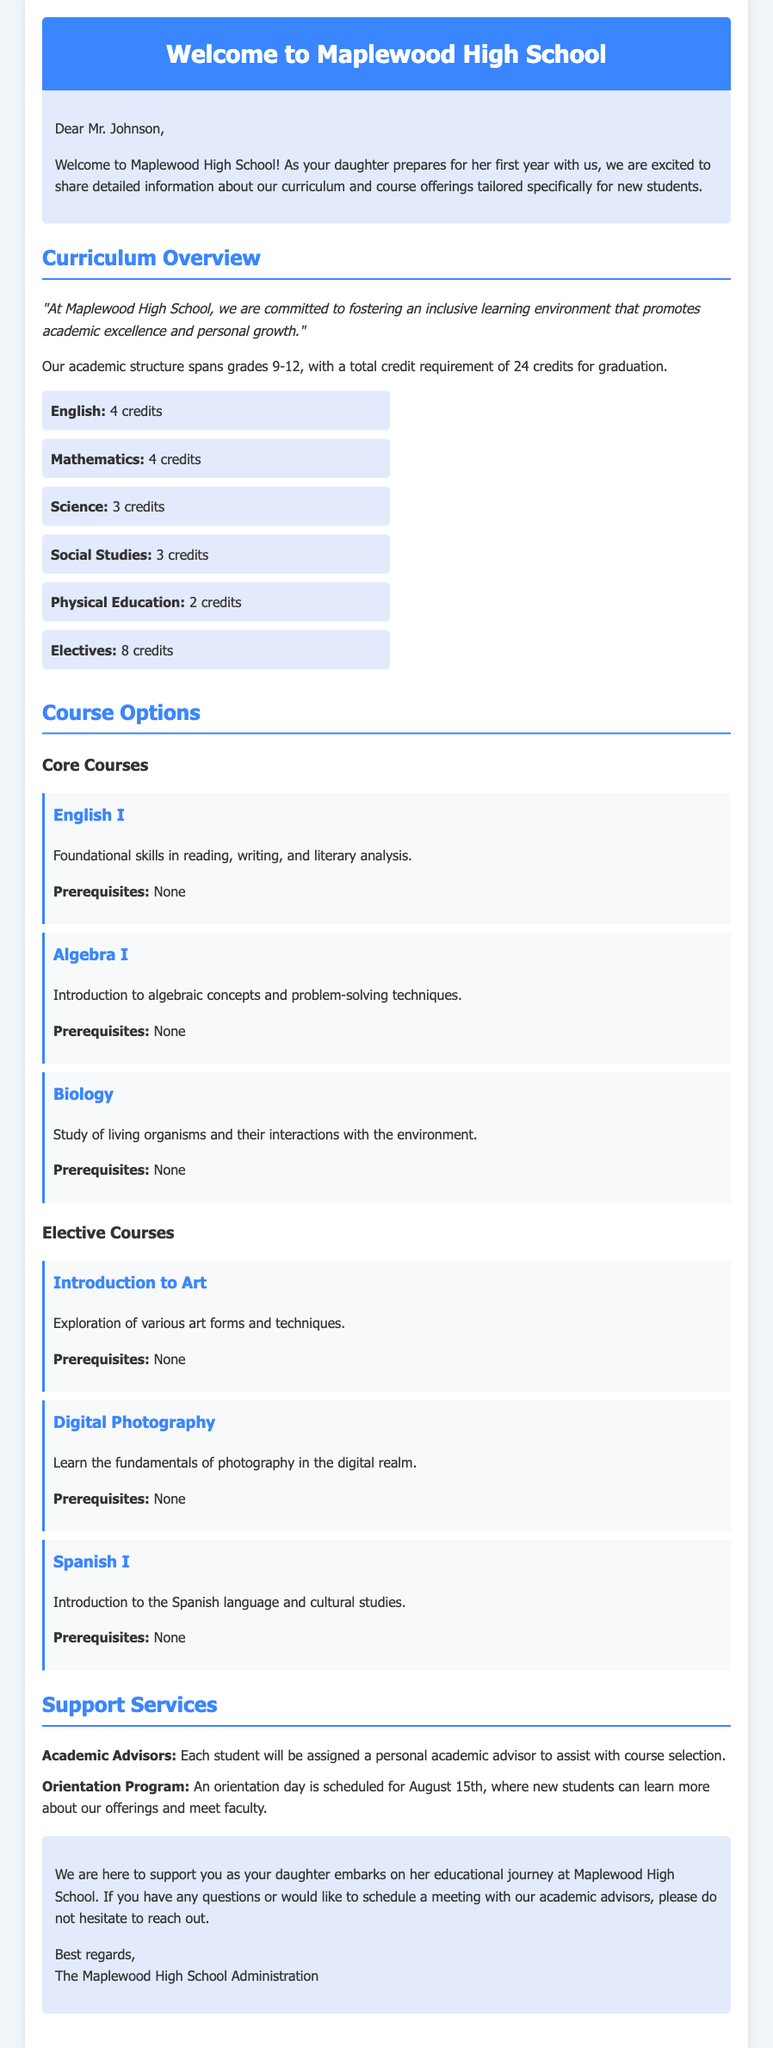What is the total credit requirement for graduation? The total credit requirement for graduation is detailed in the curriculum overview as 24 credits.
Answer: 24 credits When is the orientation program scheduled? The orientation program is mentioned to be scheduled for a specific date in the support services section, which is August 15th.
Answer: August 15th How many English credits are required? The curriculum outlines that 4 credits are required for English, which is specifically stated under the credit requirements.
Answer: 4 credits What are the prerequisites for Spanish I? The course listing for Spanish I states that there are no prerequisites required to enroll in the course.
Answer: None Who will assist students with course selection? The support services section mentions that each student will be assigned a personal academic advisor to assist with course selection.
Answer: Academic Advisors What is the main focus of the Biology course? The description of the Biology course in the course options specifically states that it focuses on the study of living organisms and their interactions with the environment.
Answer: Study of living organisms What type of skills does English I focus on? The English I course description indicates it focuses on foundational skills in reading, writing, and literary analysis.
Answer: Foundational skills How many elective credits are required? The curriculum specifies that 8 credits are required for electives, which is clearly outlined in the credit requirements section.
Answer: 8 credits 